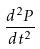Convert formula to latex. <formula><loc_0><loc_0><loc_500><loc_500>\frac { d ^ { 2 } P } { d t ^ { 2 } }</formula> 